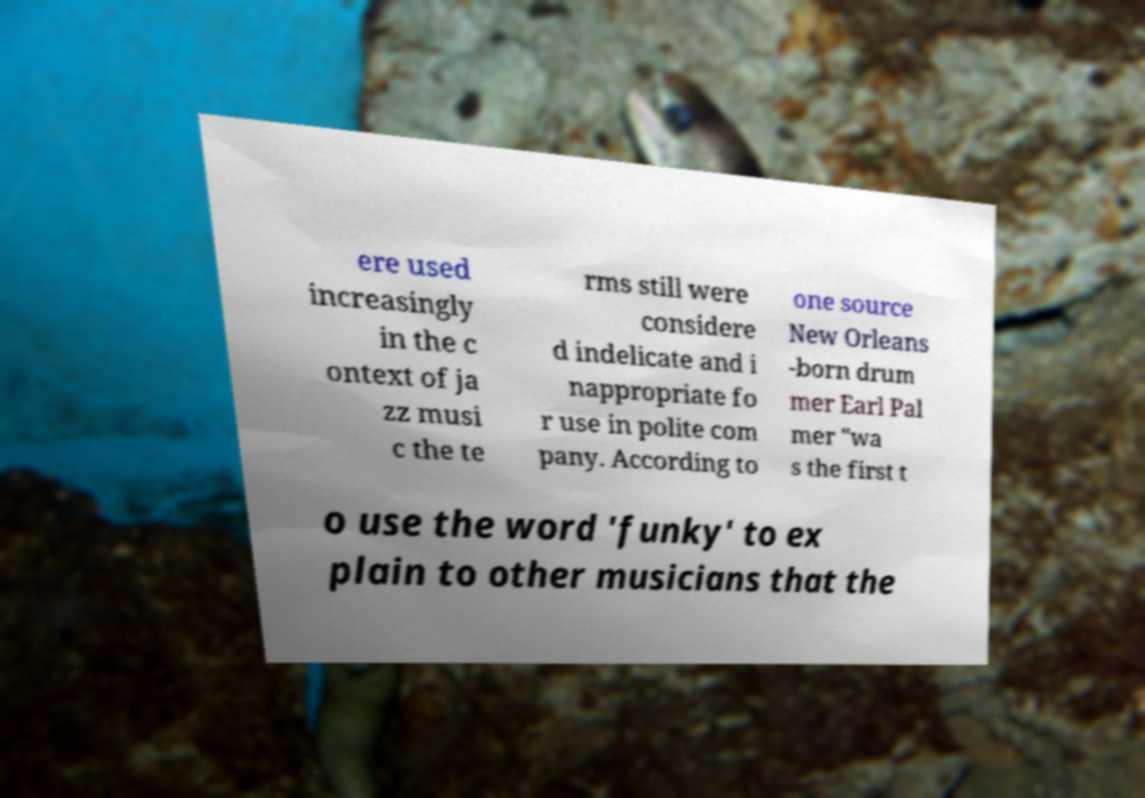I need the written content from this picture converted into text. Can you do that? ere used increasingly in the c ontext of ja zz musi c the te rms still were considere d indelicate and i nappropriate fo r use in polite com pany. According to one source New Orleans -born drum mer Earl Pal mer "wa s the first t o use the word 'funky' to ex plain to other musicians that the 